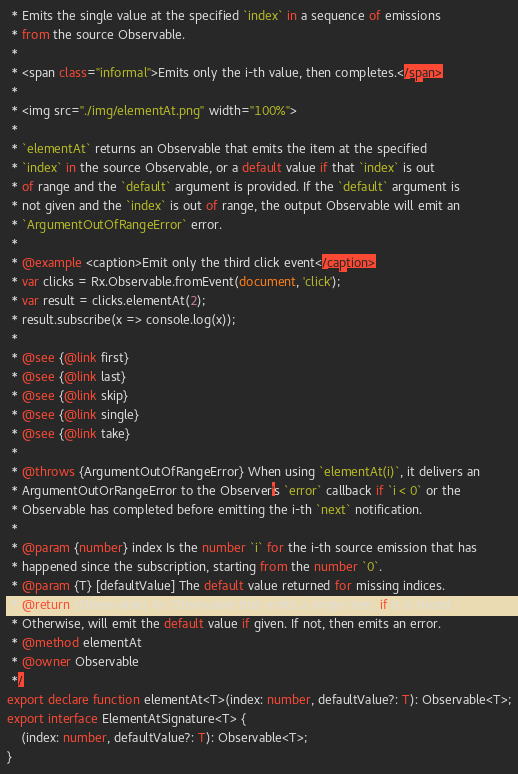<code> <loc_0><loc_0><loc_500><loc_500><_TypeScript_> * Emits the single value at the specified `index` in a sequence of emissions
 * from the source Observable.
 *
 * <span class="informal">Emits only the i-th value, then completes.</span>
 *
 * <img src="./img/elementAt.png" width="100%">
 *
 * `elementAt` returns an Observable that emits the item at the specified
 * `index` in the source Observable, or a default value if that `index` is out
 * of range and the `default` argument is provided. If the `default` argument is
 * not given and the `index` is out of range, the output Observable will emit an
 * `ArgumentOutOfRangeError` error.
 *
 * @example <caption>Emit only the third click event</caption>
 * var clicks = Rx.Observable.fromEvent(document, 'click');
 * var result = clicks.elementAt(2);
 * result.subscribe(x => console.log(x));
 *
 * @see {@link first}
 * @see {@link last}
 * @see {@link skip}
 * @see {@link single}
 * @see {@link take}
 *
 * @throws {ArgumentOutOfRangeError} When using `elementAt(i)`, it delivers an
 * ArgumentOutOrRangeError to the Observer's `error` callback if `i < 0` or the
 * Observable has completed before emitting the i-th `next` notification.
 *
 * @param {number} index Is the number `i` for the i-th source emission that has
 * happened since the subscription, starting from the number `0`.
 * @param {T} [defaultValue] The default value returned for missing indices.
 * @return {Observable} An Observable that emits a single item, if it is found.
 * Otherwise, will emit the default value if given. If not, then emits an error.
 * @method elementAt
 * @owner Observable
 */
export declare function elementAt<T>(index: number, defaultValue?: T): Observable<T>;
export interface ElementAtSignature<T> {
    (index: number, defaultValue?: T): Observable<T>;
}
</code> 